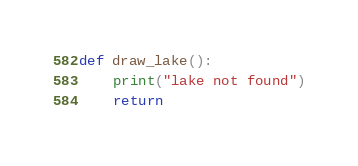<code> <loc_0><loc_0><loc_500><loc_500><_Python_>def draw_lake():
    print("lake not found")
    return</code> 